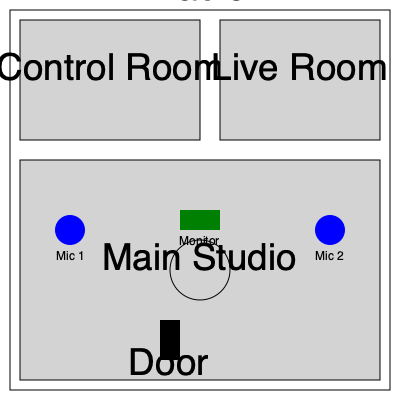Based on the floor plan of a radio studio, which equipment placement would be most beneficial for a host conducting interviews with guests? To determine the best equipment placement for conducting interviews, we need to consider several factors:

1. Studio layout: The floor plan shows a main studio, control room, and live room.

2. Microphone positions: There are two microphones (Mic 1 and Mic 2) placed on opposite sides of the central table in the main studio.

3. Table placement: A circular table is located in the center of the main studio.

4. Monitor placement: A monitor is positioned near the table, likely for visual cues or information display.

5. Interview dynamics: For interviews, the host and guest should face each other for better interaction and eye contact.

6. Audio quality: Proper microphone placement ensures clear audio capture for both the host and guest.

Given these considerations:
- The circular table allows for face-to-face interaction between the host and guest.
- The two microphones on opposite sides of the table provide dedicated audio capture for both the host and guest.
- The monitor near the table can display relevant information or cues during the interview.

This setup enables clear communication, good audio quality, and visual aids for a smooth interview process.
Answer: Mic 1 and Mic 2 on opposite sides of the central table 